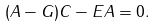Convert formula to latex. <formula><loc_0><loc_0><loc_500><loc_500>( A - G ) C - E A = 0 .</formula> 